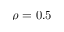Convert formula to latex. <formula><loc_0><loc_0><loc_500><loc_500>\rho = 0 . 5</formula> 